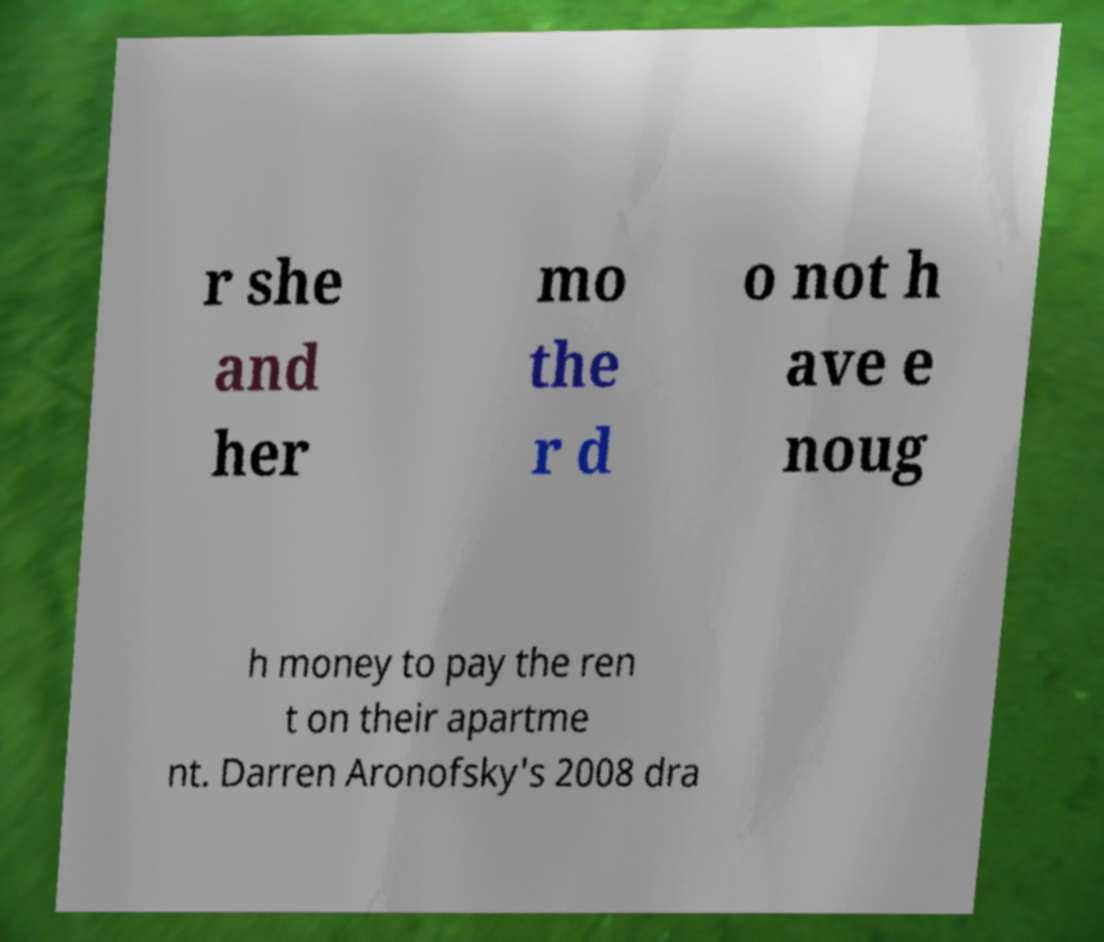For documentation purposes, I need the text within this image transcribed. Could you provide that? r she and her mo the r d o not h ave e noug h money to pay the ren t on their apartme nt. Darren Aronofsky's 2008 dra 